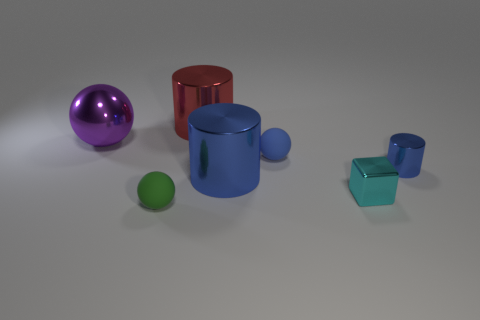There is a shiny object that is the same color as the tiny cylinder; what is its shape?
Provide a short and direct response. Cylinder. What number of green balls are behind the big red cylinder that is behind the small shiny block?
Offer a terse response. 0. Is there a brown thing of the same shape as the tiny cyan metal object?
Ensure brevity in your answer.  No. Do the ball left of the green rubber thing and the cylinder that is behind the big purple metallic ball have the same size?
Give a very brief answer. Yes. What shape is the large metal thing that is in front of the small cylinder that is right of the blue rubber ball?
Offer a very short reply. Cylinder. What number of cyan things are the same size as the red metal thing?
Give a very brief answer. 0. Is there a yellow metal cylinder?
Your answer should be very brief. No. Is there anything else of the same color as the small cylinder?
Offer a very short reply. Yes. What is the shape of the purple thing that is made of the same material as the small cyan block?
Offer a very short reply. Sphere. The rubber thing that is in front of the rubber sphere right of the metallic cylinder that is behind the large metallic sphere is what color?
Offer a terse response. Green. 